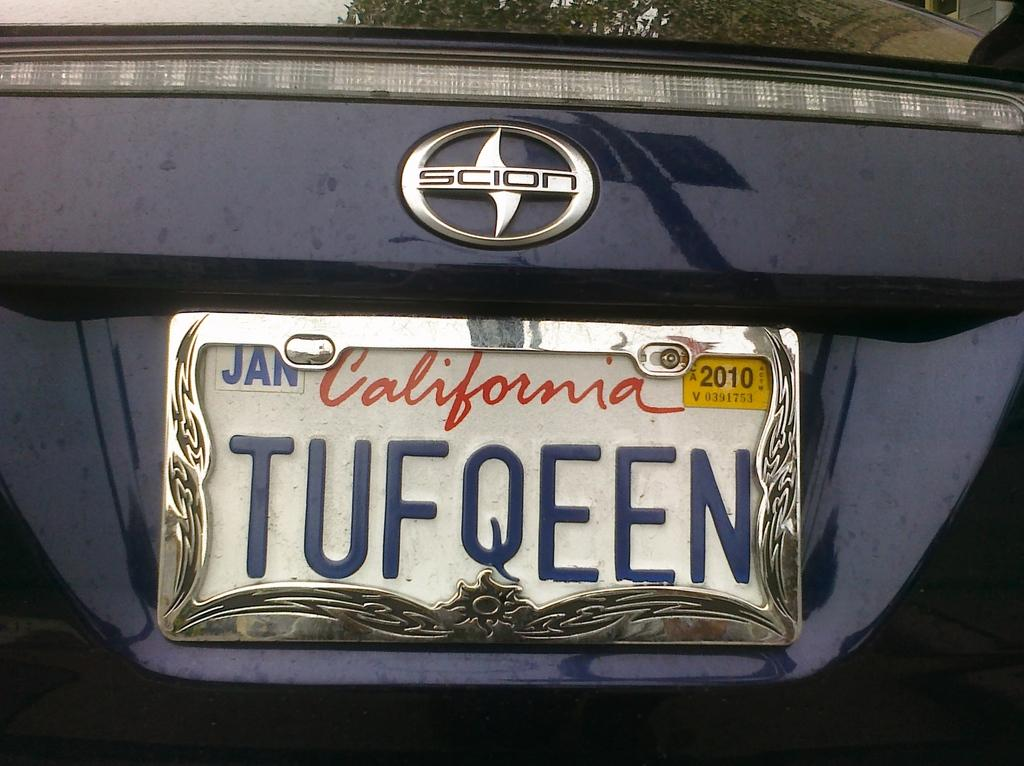<image>
Share a concise interpretation of the image provided. The California license plate on the Scion is stamped TUFQEEN. 